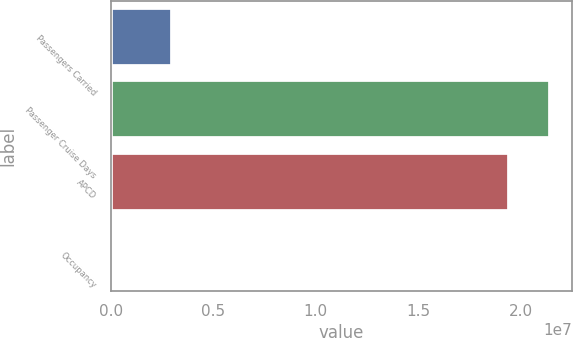<chart> <loc_0><loc_0><loc_500><loc_500><bar_chart><fcel>Passengers Carried<fcel>Passenger Cruise Days<fcel>APCD<fcel>Occupancy<nl><fcel>2.99061e+06<fcel>2.14457e+07<fcel>1.94392e+07<fcel>103.2<nl></chart> 